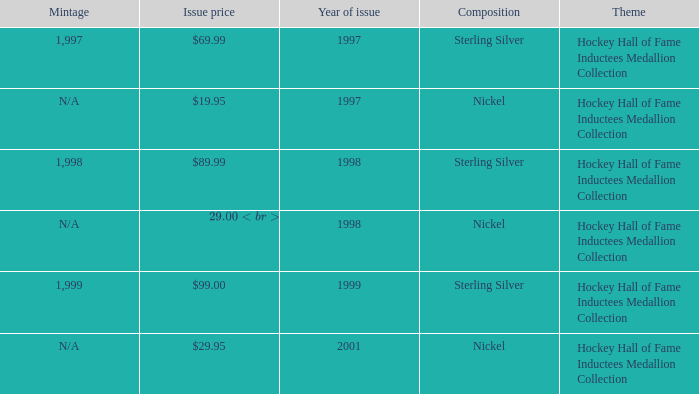Which composition has an issue price of $99.00? Sterling Silver. Give me the full table as a dictionary. {'header': ['Mintage', 'Issue price', 'Year of issue', 'Composition', 'Theme'], 'rows': [['1,997', '$69.99', '1997', 'Sterling Silver', 'Hockey Hall of Fame Inductees Medallion Collection'], ['N/A', '$19.95', '1997', 'Nickel', 'Hockey Hall of Fame Inductees Medallion Collection'], ['1,998', '$89.99', '1998', 'Sterling Silver', 'Hockey Hall of Fame Inductees Medallion Collection'], ['N/A', '$29.00 (set), $7.50 (individually)', '1998', 'Nickel', 'Hockey Hall of Fame Inductees Medallion Collection'], ['1,999', '$99.00', '1999', 'Sterling Silver', 'Hockey Hall of Fame Inductees Medallion Collection'], ['N/A', '$29.95', '2001', 'Nickel', 'Hockey Hall of Fame Inductees Medallion Collection']]} 